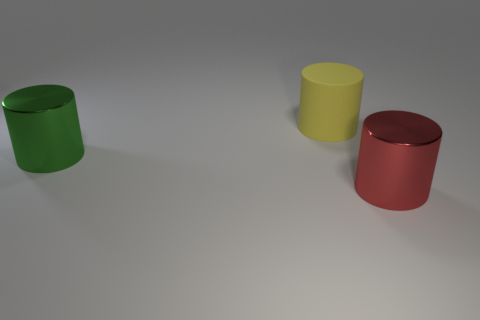Do the matte thing and the metal cylinder that is on the right side of the matte object have the same color?
Provide a succinct answer. No. What material is the green cylinder that is the same size as the red cylinder?
Your answer should be very brief. Metal. How many things are either tiny gray shiny blocks or big cylinders that are on the left side of the yellow thing?
Provide a succinct answer. 1. There is a red object; is it the same size as the metal object behind the red object?
Offer a terse response. Yes. What number of cylinders are red objects or large yellow rubber things?
Make the answer very short. 2. What number of large metal objects are both on the right side of the green metal cylinder and to the left of the red cylinder?
Offer a very short reply. 0. How many other things are the same color as the large matte object?
Offer a terse response. 0. The object that is on the left side of the yellow rubber thing has what shape?
Offer a very short reply. Cylinder. Is the large yellow cylinder made of the same material as the green cylinder?
Your answer should be very brief. No. Is there anything else that is the same size as the rubber cylinder?
Your answer should be compact. Yes. 